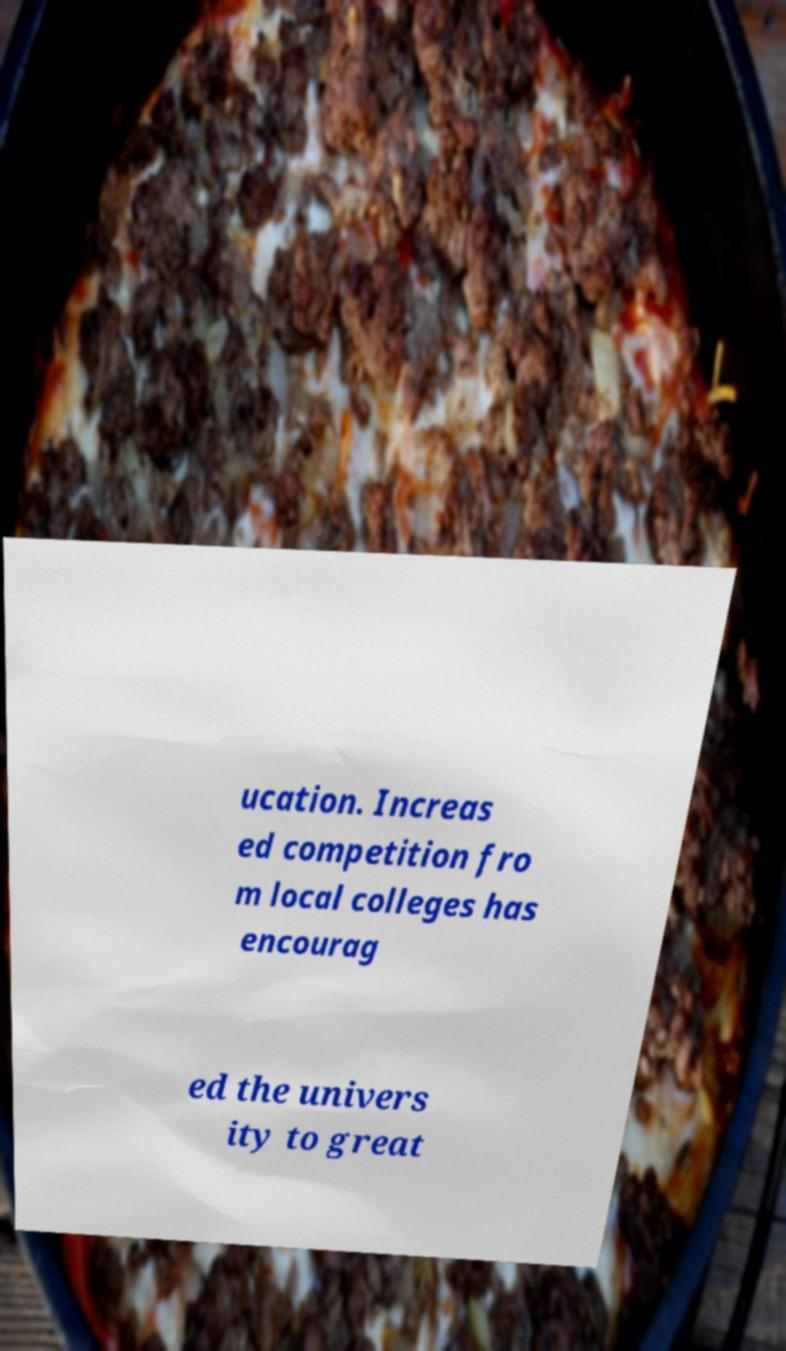Can you accurately transcribe the text from the provided image for me? ucation. Increas ed competition fro m local colleges has encourag ed the univers ity to great 